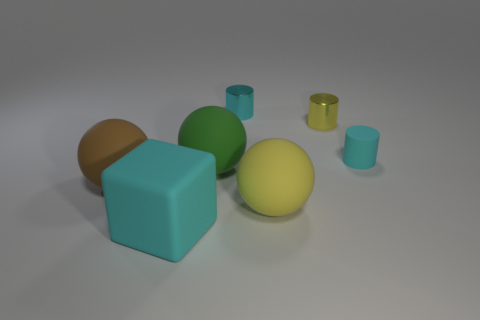There is a brown object that is the same shape as the green rubber object; what is its material?
Your response must be concise. Rubber. Is the size of the cylinder that is on the left side of the yellow matte sphere the same as the tiny yellow cylinder?
Your answer should be very brief. Yes. What is the color of the thing that is behind the tiny rubber cylinder and left of the yellow rubber sphere?
Give a very brief answer. Cyan. How many small cyan things are right of the large ball on the right side of the green ball?
Your answer should be very brief. 1. Is the shape of the large brown object the same as the big cyan thing?
Ensure brevity in your answer.  No. Is there anything else of the same color as the large rubber block?
Your answer should be very brief. Yes. There is a large yellow matte object; does it have the same shape as the big object behind the brown matte ball?
Offer a terse response. Yes. There is a thing in front of the ball that is to the right of the cyan thing behind the small yellow thing; what is its color?
Provide a short and direct response. Cyan. There is a large thing left of the cyan matte block; is its shape the same as the large cyan thing?
Your answer should be compact. No. What is the material of the large green object?
Your answer should be compact. Rubber. 